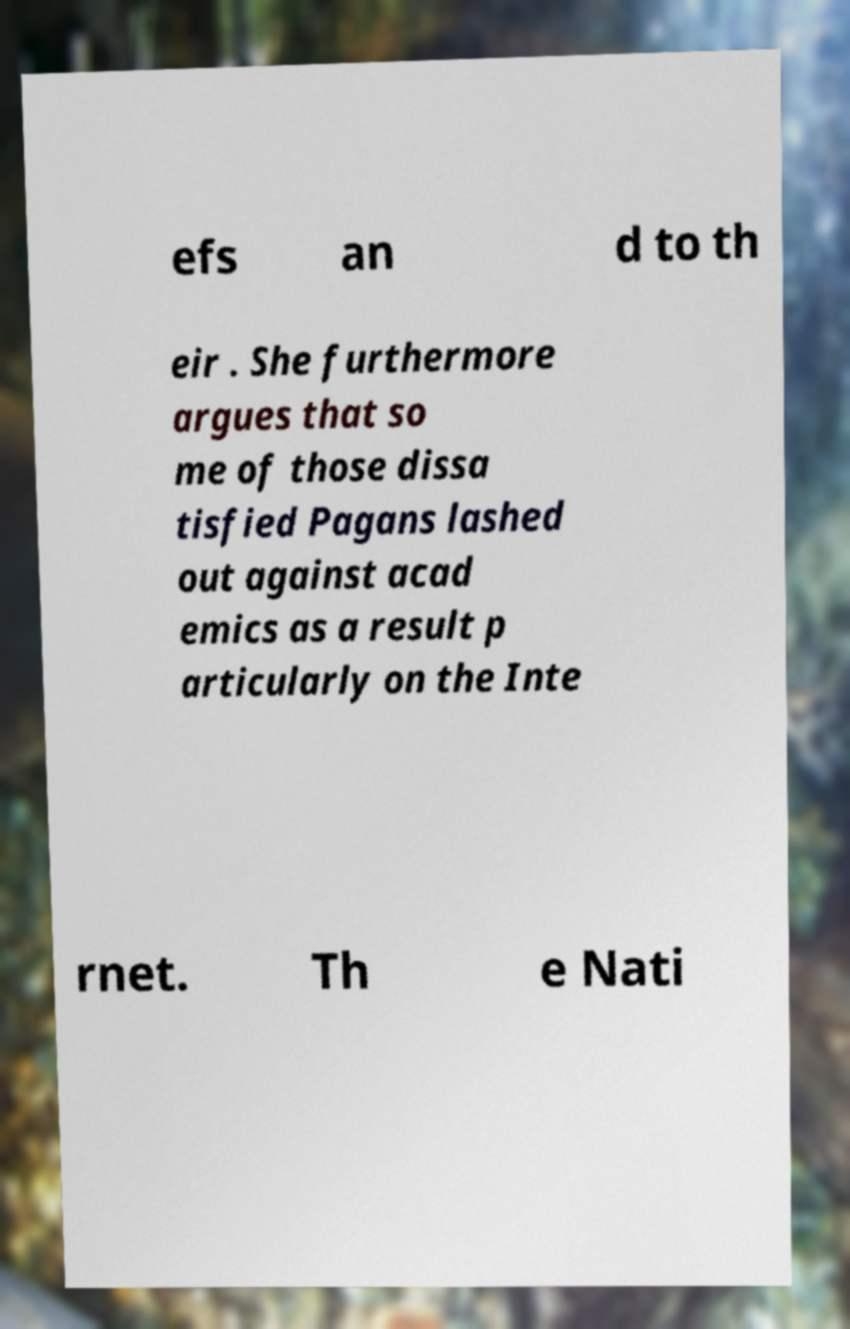I need the written content from this picture converted into text. Can you do that? efs an d to th eir . She furthermore argues that so me of those dissa tisfied Pagans lashed out against acad emics as a result p articularly on the Inte rnet. Th e Nati 